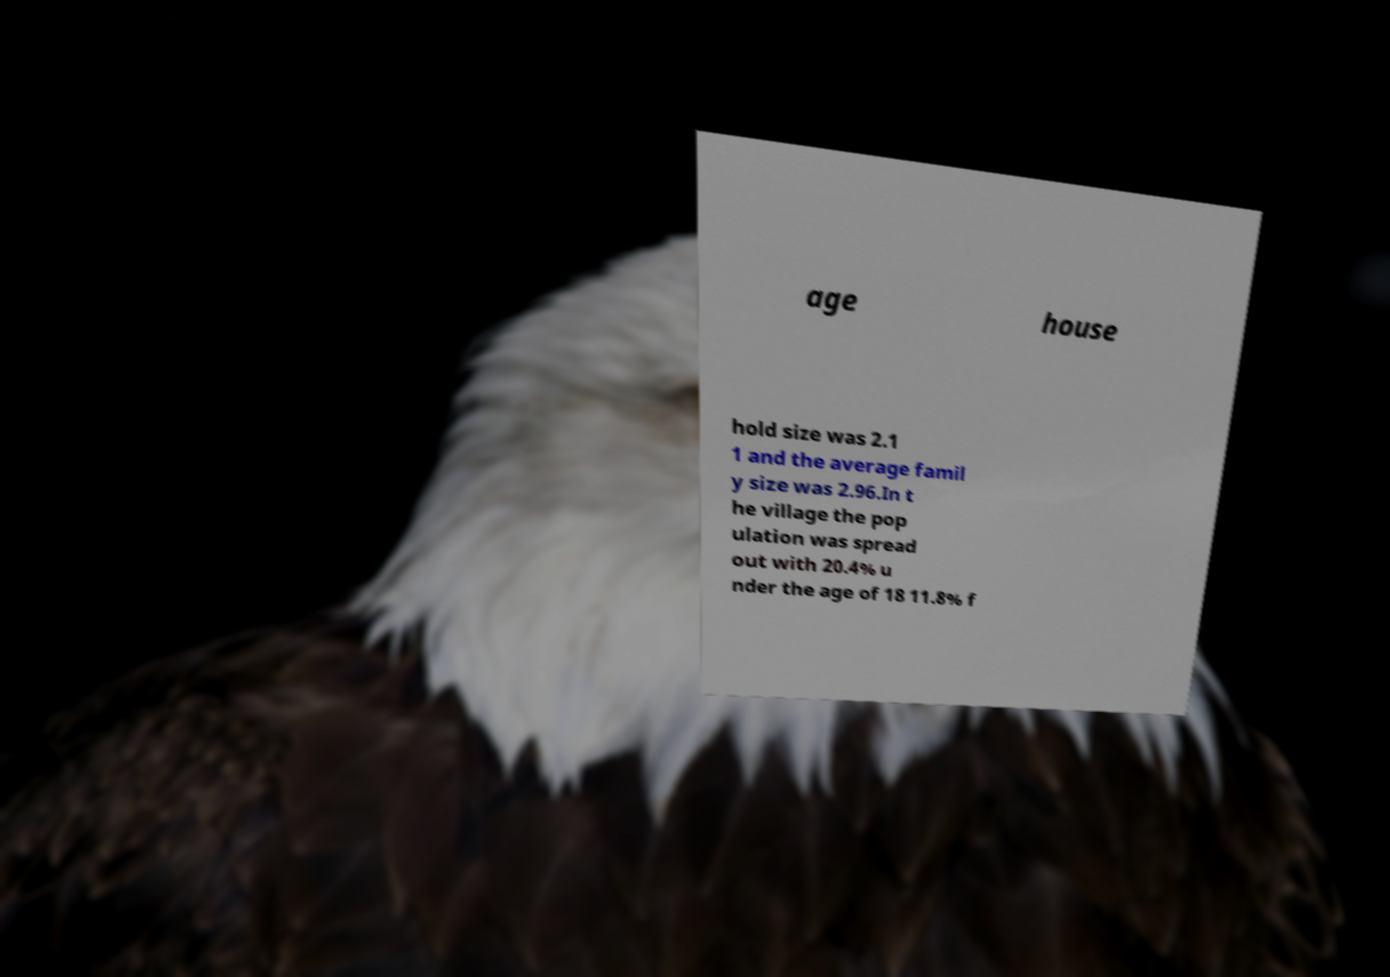I need the written content from this picture converted into text. Can you do that? age house hold size was 2.1 1 and the average famil y size was 2.96.In t he village the pop ulation was spread out with 20.4% u nder the age of 18 11.8% f 